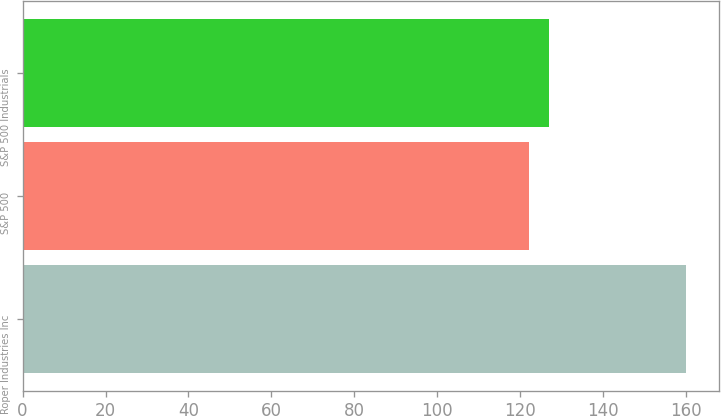Convert chart to OTSL. <chart><loc_0><loc_0><loc_500><loc_500><bar_chart><fcel>Roper Industries Inc<fcel>S&P 500<fcel>S&P 500 Industrials<nl><fcel>159.85<fcel>122.16<fcel>126.92<nl></chart> 